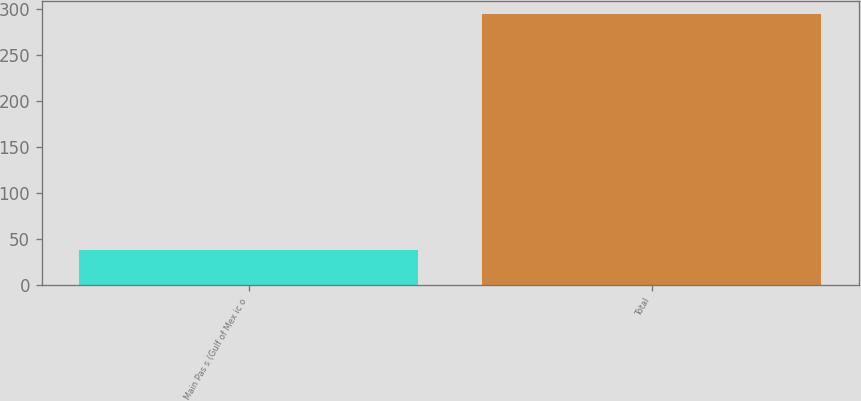Convert chart to OTSL. <chart><loc_0><loc_0><loc_500><loc_500><bar_chart><fcel>Main Pas s (Gulf of Mex ic o<fcel>Total<nl><fcel>38<fcel>294<nl></chart> 